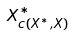Convert formula to latex. <formula><loc_0><loc_0><loc_500><loc_500>X _ { c ( X ^ { * } , X ) } ^ { * }</formula> 